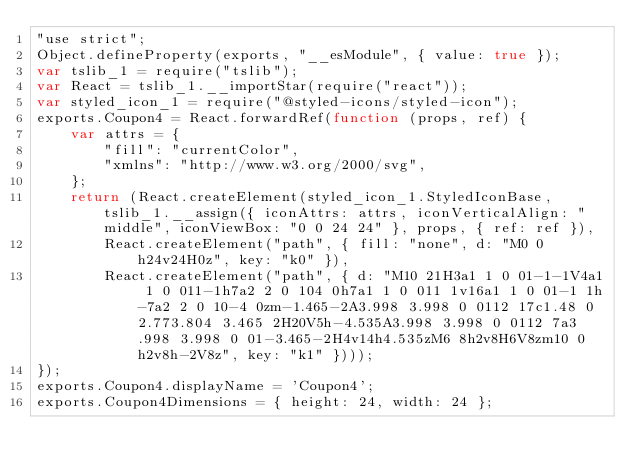<code> <loc_0><loc_0><loc_500><loc_500><_JavaScript_>"use strict";
Object.defineProperty(exports, "__esModule", { value: true });
var tslib_1 = require("tslib");
var React = tslib_1.__importStar(require("react"));
var styled_icon_1 = require("@styled-icons/styled-icon");
exports.Coupon4 = React.forwardRef(function (props, ref) {
    var attrs = {
        "fill": "currentColor",
        "xmlns": "http://www.w3.org/2000/svg",
    };
    return (React.createElement(styled_icon_1.StyledIconBase, tslib_1.__assign({ iconAttrs: attrs, iconVerticalAlign: "middle", iconViewBox: "0 0 24 24" }, props, { ref: ref }),
        React.createElement("path", { fill: "none", d: "M0 0h24v24H0z", key: "k0" }),
        React.createElement("path", { d: "M10 21H3a1 1 0 01-1-1V4a1 1 0 011-1h7a2 2 0 104 0h7a1 1 0 011 1v16a1 1 0 01-1 1h-7a2 2 0 10-4 0zm-1.465-2A3.998 3.998 0 0112 17c1.48 0 2.773.804 3.465 2H20V5h-4.535A3.998 3.998 0 0112 7a3.998 3.998 0 01-3.465-2H4v14h4.535zM6 8h2v8H6V8zm10 0h2v8h-2V8z", key: "k1" })));
});
exports.Coupon4.displayName = 'Coupon4';
exports.Coupon4Dimensions = { height: 24, width: 24 };
</code> 